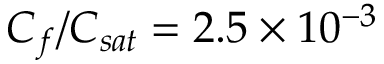Convert formula to latex. <formula><loc_0><loc_0><loc_500><loc_500>C _ { f } / C _ { s a t } = 2 . 5 \times 1 0 ^ { - 3 }</formula> 